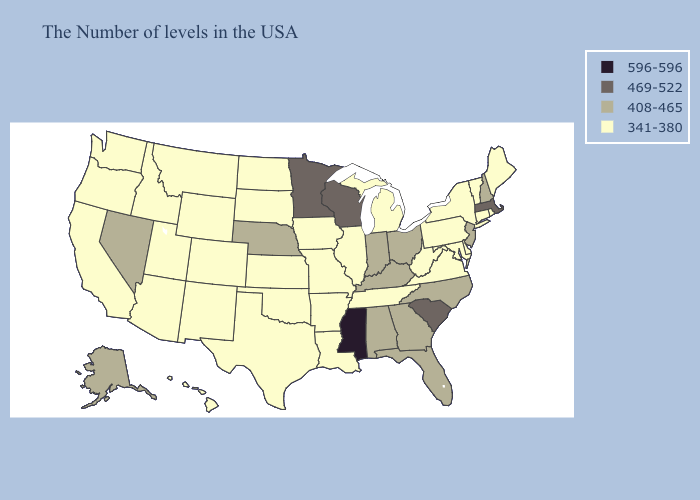Does Alaska have the lowest value in the West?
Be succinct. No. Does Missouri have the highest value in the USA?
Concise answer only. No. Among the states that border Nevada , which have the lowest value?
Short answer required. Utah, Arizona, Idaho, California, Oregon. Among the states that border Georgia , does North Carolina have the highest value?
Concise answer only. No. What is the value of Oregon?
Keep it brief. 341-380. Which states have the lowest value in the South?
Short answer required. Delaware, Maryland, Virginia, West Virginia, Tennessee, Louisiana, Arkansas, Oklahoma, Texas. Which states hav the highest value in the Northeast?
Answer briefly. Massachusetts. Among the states that border Utah , which have the highest value?
Short answer required. Nevada. Name the states that have a value in the range 469-522?
Concise answer only. Massachusetts, South Carolina, Wisconsin, Minnesota. Name the states that have a value in the range 469-522?
Give a very brief answer. Massachusetts, South Carolina, Wisconsin, Minnesota. Name the states that have a value in the range 469-522?
Write a very short answer. Massachusetts, South Carolina, Wisconsin, Minnesota. Which states hav the highest value in the MidWest?
Answer briefly. Wisconsin, Minnesota. Does Kentucky have a higher value than Washington?
Short answer required. Yes. What is the highest value in states that border Iowa?
Concise answer only. 469-522. 